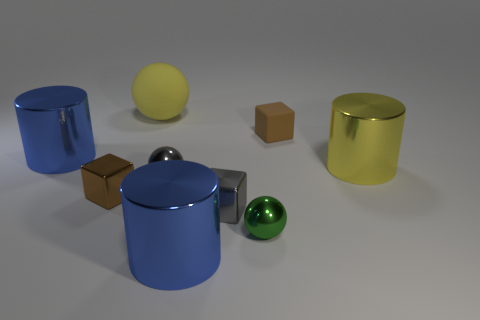Are all the objects in the image resting on the same surface? Yes, all the objects in the image appear to be resting on the same flat surface. The shadows cast by each object are consistent with a single light source illuminating a uniform plane. Could you describe the arrangement of the objects? Is there a pattern? The objects are arranged in a seemingly random order with no immediately discernible pattern. This arrangement might suggest a casual or natural placement, perhaps corresponding to how objects might be found in a real-world setting. 